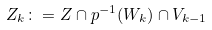Convert formula to latex. <formula><loc_0><loc_0><loc_500><loc_500>Z _ { k } \colon = Z \cap p ^ { - 1 } ( W _ { k } ) \cap V _ { k - 1 }</formula> 